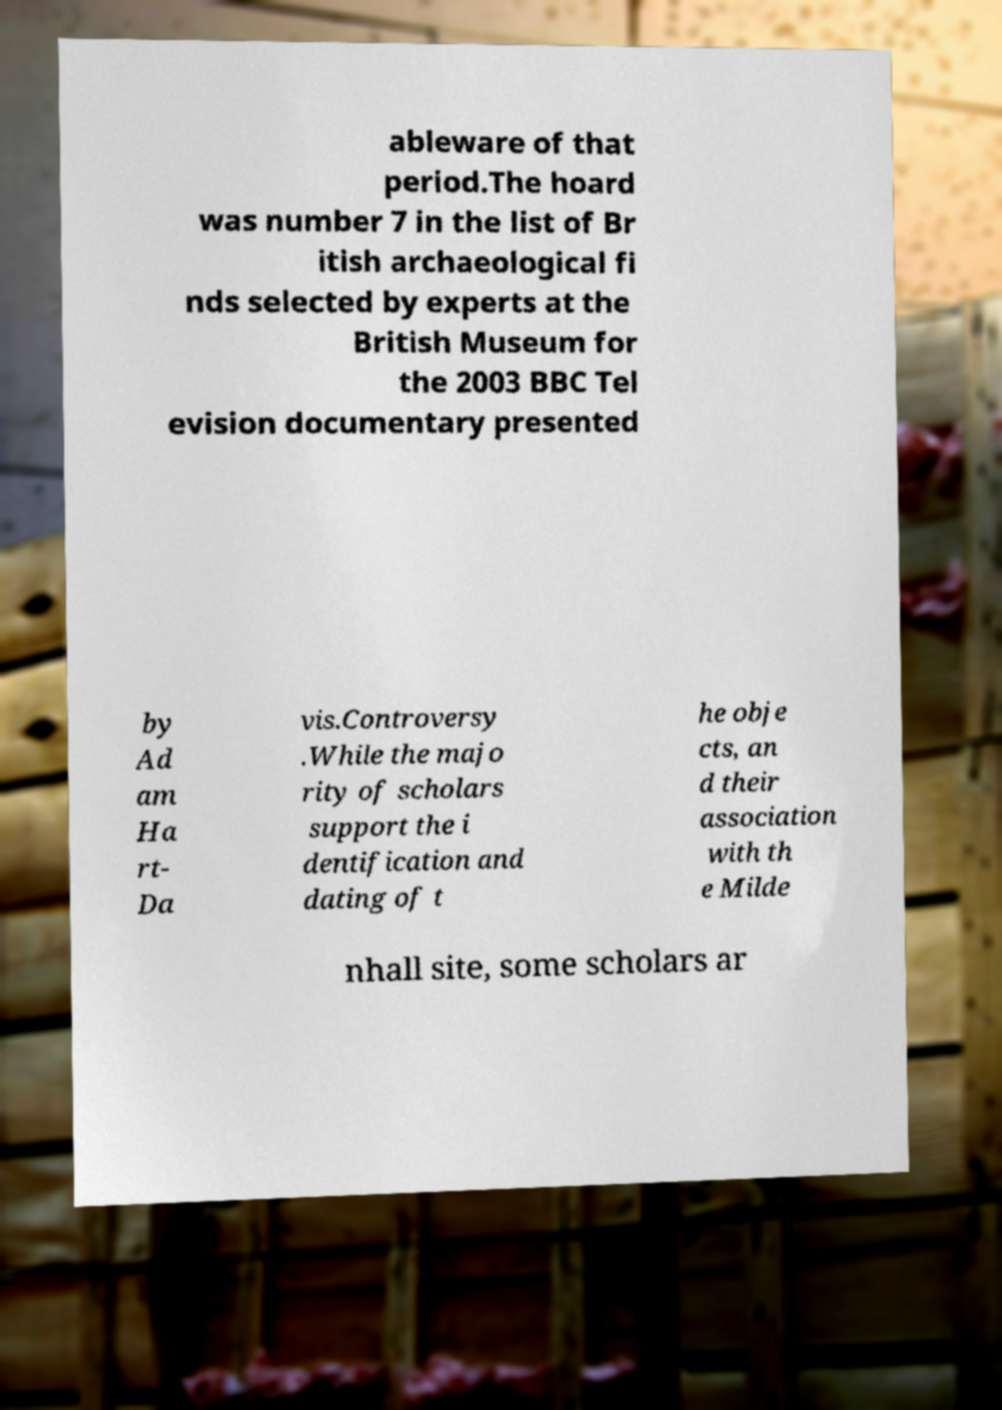Could you extract and type out the text from this image? ableware of that period.The hoard was number 7 in the list of Br itish archaeological fi nds selected by experts at the British Museum for the 2003 BBC Tel evision documentary presented by Ad am Ha rt- Da vis.Controversy .While the majo rity of scholars support the i dentification and dating of t he obje cts, an d their association with th e Milde nhall site, some scholars ar 